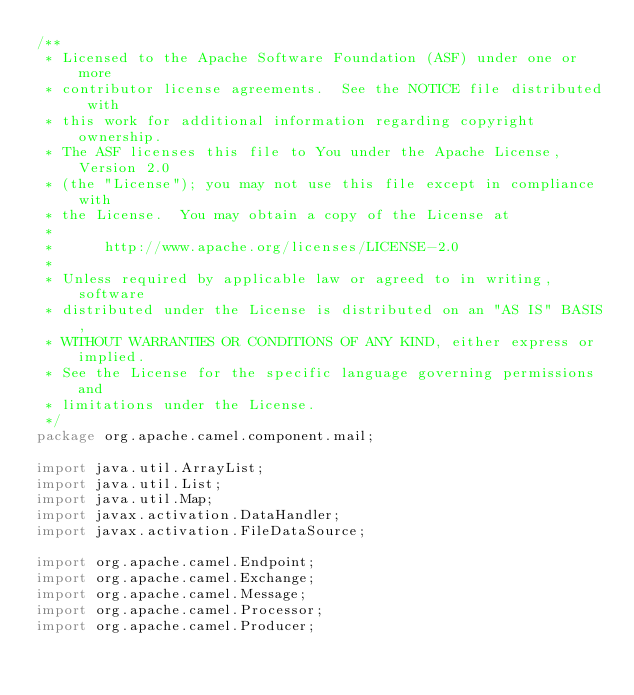<code> <loc_0><loc_0><loc_500><loc_500><_Java_>/**
 * Licensed to the Apache Software Foundation (ASF) under one or more
 * contributor license agreements.  See the NOTICE file distributed with
 * this work for additional information regarding copyright ownership.
 * The ASF licenses this file to You under the Apache License, Version 2.0
 * (the "License"); you may not use this file except in compliance with
 * the License.  You may obtain a copy of the License at
 *
 *      http://www.apache.org/licenses/LICENSE-2.0
 *
 * Unless required by applicable law or agreed to in writing, software
 * distributed under the License is distributed on an "AS IS" BASIS,
 * WITHOUT WARRANTIES OR CONDITIONS OF ANY KIND, either express or implied.
 * See the License for the specific language governing permissions and
 * limitations under the License.
 */
package org.apache.camel.component.mail;

import java.util.ArrayList;
import java.util.List;
import java.util.Map;
import javax.activation.DataHandler;
import javax.activation.FileDataSource;

import org.apache.camel.Endpoint;
import org.apache.camel.Exchange;
import org.apache.camel.Message;
import org.apache.camel.Processor;
import org.apache.camel.Producer;</code> 